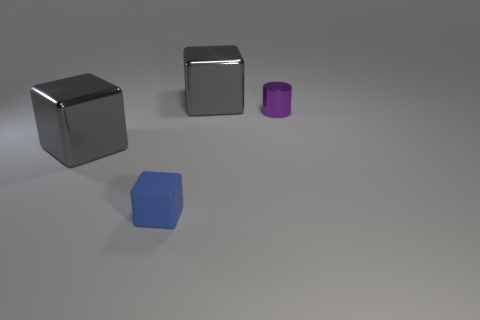Are the blue object and the purple object made of the same material?
Offer a terse response. No. What number of things are matte spheres or metallic objects?
Your answer should be compact. 3. What size is the rubber thing?
Your answer should be compact. Small. Is the number of big red matte blocks less than the number of large gray metal blocks?
Offer a very short reply. Yes. How many large metallic blocks have the same color as the tiny metal object?
Your response must be concise. 0. There is a tiny thing to the right of the blue object; is its color the same as the small cube?
Give a very brief answer. No. There is a big object right of the tiny matte block; what shape is it?
Give a very brief answer. Cube. There is a blue object in front of the small purple thing; is there a large gray thing that is in front of it?
Provide a short and direct response. No. How many large blocks have the same material as the small purple object?
Offer a very short reply. 2. There is a metallic object right of the big gray shiny cube behind the tiny purple cylinder behind the blue rubber object; what is its size?
Offer a terse response. Small. 